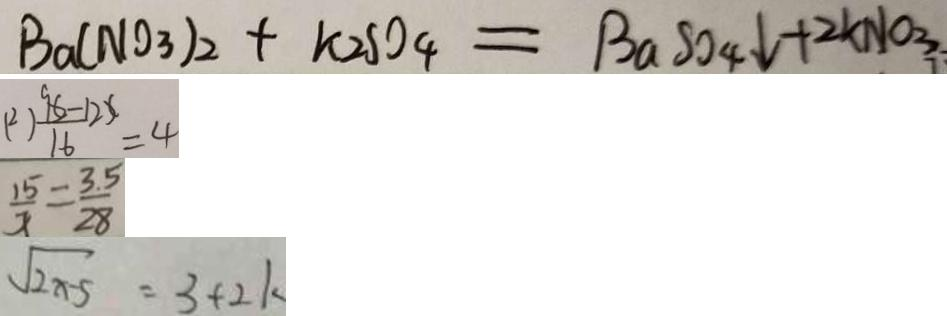Convert formula to latex. <formula><loc_0><loc_0><loc_500><loc_500>B a ( N O _ { 3 } ) _ { 2 } + k _ { 2 } S O _ { 4 } = B a S O _ { 4 } \downarrow + 2 K N O _ { 3 } 
 ( 2 ) \frac { 9 6 - 1 2 x } { 1 6 } = 4 
 \frac { 1 5 } { x } = \frac { 3 . 5 } { 2 8 } 
 \sqrt { 2 x - 5 } = 3 + 2 k</formula> 